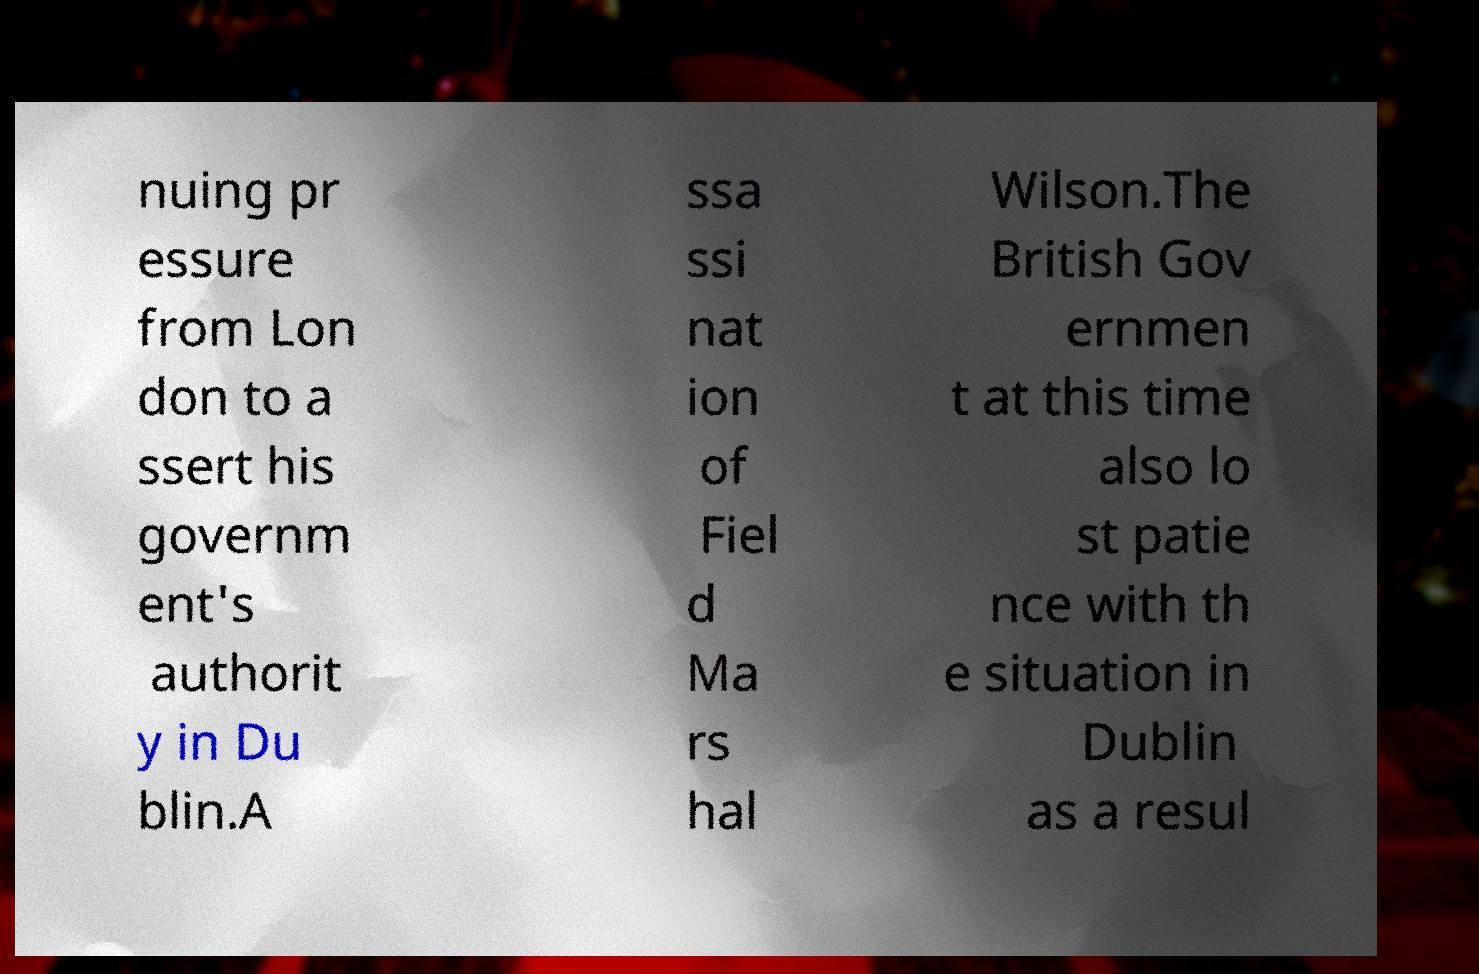What messages or text are displayed in this image? I need them in a readable, typed format. nuing pr essure from Lon don to a ssert his governm ent's authorit y in Du blin.A ssa ssi nat ion of Fiel d Ma rs hal Wilson.The British Gov ernmen t at this time also lo st patie nce with th e situation in Dublin as a resul 